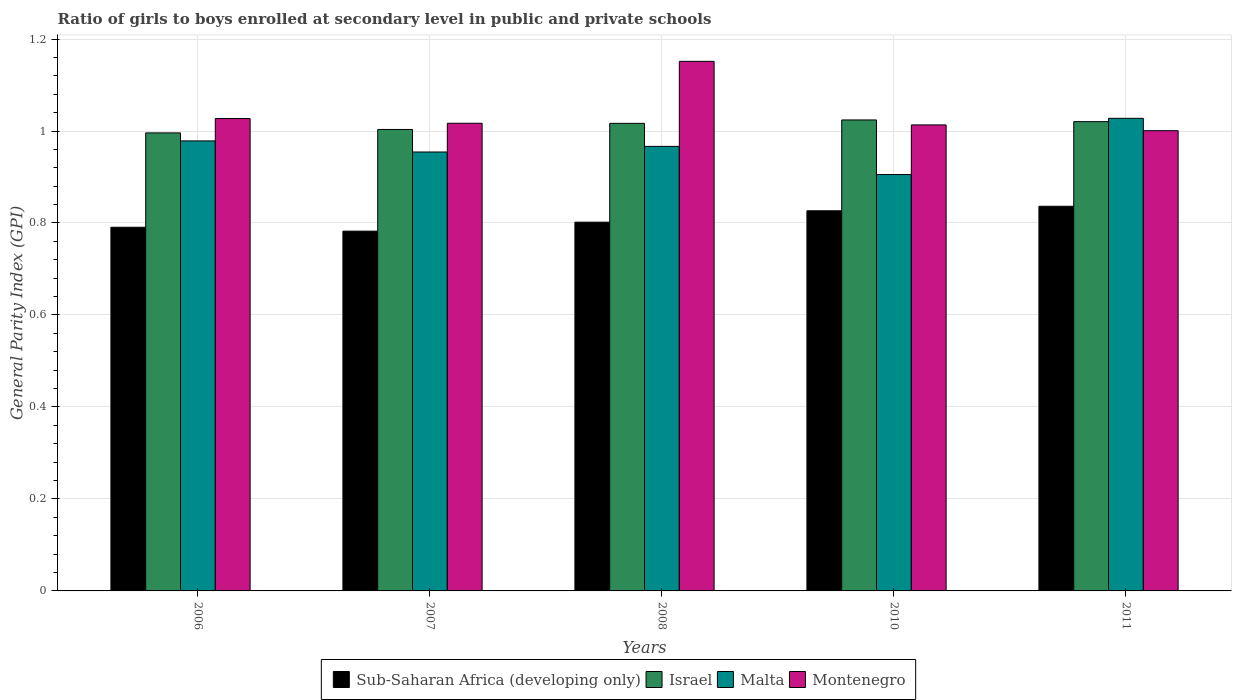How many different coloured bars are there?
Keep it short and to the point. 4. How many groups of bars are there?
Provide a short and direct response. 5. Are the number of bars per tick equal to the number of legend labels?
Provide a succinct answer. Yes. How many bars are there on the 2nd tick from the left?
Keep it short and to the point. 4. How many bars are there on the 1st tick from the right?
Keep it short and to the point. 4. In how many cases, is the number of bars for a given year not equal to the number of legend labels?
Offer a terse response. 0. What is the general parity index in Malta in 2007?
Give a very brief answer. 0.95. Across all years, what is the maximum general parity index in Israel?
Offer a terse response. 1.02. Across all years, what is the minimum general parity index in Israel?
Ensure brevity in your answer.  1. What is the total general parity index in Sub-Saharan Africa (developing only) in the graph?
Make the answer very short. 4.04. What is the difference between the general parity index in Sub-Saharan Africa (developing only) in 2007 and that in 2008?
Offer a very short reply. -0.02. What is the difference between the general parity index in Montenegro in 2007 and the general parity index in Malta in 2006?
Your answer should be compact. 0.04. What is the average general parity index in Israel per year?
Ensure brevity in your answer.  1.01. In the year 2010, what is the difference between the general parity index in Montenegro and general parity index in Israel?
Ensure brevity in your answer.  -0.01. What is the ratio of the general parity index in Malta in 2006 to that in 2008?
Keep it short and to the point. 1.01. Is the difference between the general parity index in Montenegro in 2006 and 2011 greater than the difference between the general parity index in Israel in 2006 and 2011?
Offer a terse response. Yes. What is the difference between the highest and the second highest general parity index in Israel?
Your answer should be very brief. 0. What is the difference between the highest and the lowest general parity index in Montenegro?
Your answer should be compact. 0.15. In how many years, is the general parity index in Sub-Saharan Africa (developing only) greater than the average general parity index in Sub-Saharan Africa (developing only) taken over all years?
Your response must be concise. 2. What does the 1st bar from the left in 2010 represents?
Your answer should be compact. Sub-Saharan Africa (developing only). What does the 1st bar from the right in 2006 represents?
Offer a terse response. Montenegro. Is it the case that in every year, the sum of the general parity index in Sub-Saharan Africa (developing only) and general parity index in Israel is greater than the general parity index in Montenegro?
Your response must be concise. Yes. How many bars are there?
Make the answer very short. 20. Are all the bars in the graph horizontal?
Your response must be concise. No. How many years are there in the graph?
Ensure brevity in your answer.  5. What is the difference between two consecutive major ticks on the Y-axis?
Your response must be concise. 0.2. Are the values on the major ticks of Y-axis written in scientific E-notation?
Keep it short and to the point. No. Does the graph contain grids?
Your answer should be compact. Yes. How many legend labels are there?
Give a very brief answer. 4. How are the legend labels stacked?
Provide a succinct answer. Horizontal. What is the title of the graph?
Offer a terse response. Ratio of girls to boys enrolled at secondary level in public and private schools. What is the label or title of the X-axis?
Provide a succinct answer. Years. What is the label or title of the Y-axis?
Provide a succinct answer. General Parity Index (GPI). What is the General Parity Index (GPI) of Sub-Saharan Africa (developing only) in 2006?
Provide a succinct answer. 0.79. What is the General Parity Index (GPI) of Israel in 2006?
Your answer should be very brief. 1. What is the General Parity Index (GPI) of Malta in 2006?
Offer a terse response. 0.98. What is the General Parity Index (GPI) in Montenegro in 2006?
Your answer should be compact. 1.03. What is the General Parity Index (GPI) in Sub-Saharan Africa (developing only) in 2007?
Keep it short and to the point. 0.78. What is the General Parity Index (GPI) of Israel in 2007?
Provide a succinct answer. 1. What is the General Parity Index (GPI) of Malta in 2007?
Your response must be concise. 0.95. What is the General Parity Index (GPI) in Montenegro in 2007?
Make the answer very short. 1.02. What is the General Parity Index (GPI) in Sub-Saharan Africa (developing only) in 2008?
Keep it short and to the point. 0.8. What is the General Parity Index (GPI) in Israel in 2008?
Ensure brevity in your answer.  1.02. What is the General Parity Index (GPI) of Malta in 2008?
Offer a very short reply. 0.97. What is the General Parity Index (GPI) of Montenegro in 2008?
Offer a terse response. 1.15. What is the General Parity Index (GPI) of Sub-Saharan Africa (developing only) in 2010?
Provide a short and direct response. 0.83. What is the General Parity Index (GPI) of Israel in 2010?
Give a very brief answer. 1.02. What is the General Parity Index (GPI) of Malta in 2010?
Ensure brevity in your answer.  0.91. What is the General Parity Index (GPI) of Montenegro in 2010?
Offer a terse response. 1.01. What is the General Parity Index (GPI) in Sub-Saharan Africa (developing only) in 2011?
Your answer should be compact. 0.84. What is the General Parity Index (GPI) of Israel in 2011?
Offer a terse response. 1.02. What is the General Parity Index (GPI) in Malta in 2011?
Provide a succinct answer. 1.03. What is the General Parity Index (GPI) of Montenegro in 2011?
Ensure brevity in your answer.  1. Across all years, what is the maximum General Parity Index (GPI) of Sub-Saharan Africa (developing only)?
Provide a short and direct response. 0.84. Across all years, what is the maximum General Parity Index (GPI) in Israel?
Your answer should be very brief. 1.02. Across all years, what is the maximum General Parity Index (GPI) of Malta?
Keep it short and to the point. 1.03. Across all years, what is the maximum General Parity Index (GPI) in Montenegro?
Ensure brevity in your answer.  1.15. Across all years, what is the minimum General Parity Index (GPI) of Sub-Saharan Africa (developing only)?
Offer a terse response. 0.78. Across all years, what is the minimum General Parity Index (GPI) in Israel?
Offer a very short reply. 1. Across all years, what is the minimum General Parity Index (GPI) in Malta?
Offer a very short reply. 0.91. Across all years, what is the minimum General Parity Index (GPI) of Montenegro?
Your answer should be compact. 1. What is the total General Parity Index (GPI) in Sub-Saharan Africa (developing only) in the graph?
Ensure brevity in your answer.  4.04. What is the total General Parity Index (GPI) in Israel in the graph?
Your response must be concise. 5.06. What is the total General Parity Index (GPI) in Malta in the graph?
Offer a terse response. 4.83. What is the total General Parity Index (GPI) in Montenegro in the graph?
Provide a short and direct response. 5.21. What is the difference between the General Parity Index (GPI) in Sub-Saharan Africa (developing only) in 2006 and that in 2007?
Keep it short and to the point. 0.01. What is the difference between the General Parity Index (GPI) in Israel in 2006 and that in 2007?
Your answer should be very brief. -0.01. What is the difference between the General Parity Index (GPI) of Malta in 2006 and that in 2007?
Keep it short and to the point. 0.02. What is the difference between the General Parity Index (GPI) in Montenegro in 2006 and that in 2007?
Your response must be concise. 0.01. What is the difference between the General Parity Index (GPI) of Sub-Saharan Africa (developing only) in 2006 and that in 2008?
Keep it short and to the point. -0.01. What is the difference between the General Parity Index (GPI) of Israel in 2006 and that in 2008?
Keep it short and to the point. -0.02. What is the difference between the General Parity Index (GPI) of Malta in 2006 and that in 2008?
Offer a very short reply. 0.01. What is the difference between the General Parity Index (GPI) in Montenegro in 2006 and that in 2008?
Give a very brief answer. -0.12. What is the difference between the General Parity Index (GPI) of Sub-Saharan Africa (developing only) in 2006 and that in 2010?
Give a very brief answer. -0.04. What is the difference between the General Parity Index (GPI) of Israel in 2006 and that in 2010?
Keep it short and to the point. -0.03. What is the difference between the General Parity Index (GPI) of Malta in 2006 and that in 2010?
Make the answer very short. 0.07. What is the difference between the General Parity Index (GPI) in Montenegro in 2006 and that in 2010?
Keep it short and to the point. 0.01. What is the difference between the General Parity Index (GPI) in Sub-Saharan Africa (developing only) in 2006 and that in 2011?
Offer a terse response. -0.05. What is the difference between the General Parity Index (GPI) of Israel in 2006 and that in 2011?
Make the answer very short. -0.02. What is the difference between the General Parity Index (GPI) in Malta in 2006 and that in 2011?
Your response must be concise. -0.05. What is the difference between the General Parity Index (GPI) in Montenegro in 2006 and that in 2011?
Offer a very short reply. 0.03. What is the difference between the General Parity Index (GPI) of Sub-Saharan Africa (developing only) in 2007 and that in 2008?
Offer a terse response. -0.02. What is the difference between the General Parity Index (GPI) in Israel in 2007 and that in 2008?
Your response must be concise. -0.01. What is the difference between the General Parity Index (GPI) of Malta in 2007 and that in 2008?
Your answer should be compact. -0.01. What is the difference between the General Parity Index (GPI) in Montenegro in 2007 and that in 2008?
Make the answer very short. -0.13. What is the difference between the General Parity Index (GPI) of Sub-Saharan Africa (developing only) in 2007 and that in 2010?
Keep it short and to the point. -0.04. What is the difference between the General Parity Index (GPI) in Israel in 2007 and that in 2010?
Your response must be concise. -0.02. What is the difference between the General Parity Index (GPI) of Malta in 2007 and that in 2010?
Give a very brief answer. 0.05. What is the difference between the General Parity Index (GPI) of Montenegro in 2007 and that in 2010?
Offer a very short reply. 0. What is the difference between the General Parity Index (GPI) in Sub-Saharan Africa (developing only) in 2007 and that in 2011?
Offer a terse response. -0.05. What is the difference between the General Parity Index (GPI) of Israel in 2007 and that in 2011?
Offer a very short reply. -0.02. What is the difference between the General Parity Index (GPI) in Malta in 2007 and that in 2011?
Your answer should be very brief. -0.07. What is the difference between the General Parity Index (GPI) in Montenegro in 2007 and that in 2011?
Offer a terse response. 0.02. What is the difference between the General Parity Index (GPI) in Sub-Saharan Africa (developing only) in 2008 and that in 2010?
Keep it short and to the point. -0.02. What is the difference between the General Parity Index (GPI) of Israel in 2008 and that in 2010?
Keep it short and to the point. -0.01. What is the difference between the General Parity Index (GPI) of Malta in 2008 and that in 2010?
Your response must be concise. 0.06. What is the difference between the General Parity Index (GPI) of Montenegro in 2008 and that in 2010?
Your answer should be very brief. 0.14. What is the difference between the General Parity Index (GPI) of Sub-Saharan Africa (developing only) in 2008 and that in 2011?
Provide a short and direct response. -0.03. What is the difference between the General Parity Index (GPI) in Israel in 2008 and that in 2011?
Keep it short and to the point. -0. What is the difference between the General Parity Index (GPI) of Malta in 2008 and that in 2011?
Keep it short and to the point. -0.06. What is the difference between the General Parity Index (GPI) in Montenegro in 2008 and that in 2011?
Ensure brevity in your answer.  0.15. What is the difference between the General Parity Index (GPI) of Sub-Saharan Africa (developing only) in 2010 and that in 2011?
Your answer should be very brief. -0.01. What is the difference between the General Parity Index (GPI) in Israel in 2010 and that in 2011?
Ensure brevity in your answer.  0. What is the difference between the General Parity Index (GPI) of Malta in 2010 and that in 2011?
Offer a terse response. -0.12. What is the difference between the General Parity Index (GPI) in Montenegro in 2010 and that in 2011?
Provide a short and direct response. 0.01. What is the difference between the General Parity Index (GPI) of Sub-Saharan Africa (developing only) in 2006 and the General Parity Index (GPI) of Israel in 2007?
Offer a very short reply. -0.21. What is the difference between the General Parity Index (GPI) of Sub-Saharan Africa (developing only) in 2006 and the General Parity Index (GPI) of Malta in 2007?
Offer a terse response. -0.16. What is the difference between the General Parity Index (GPI) in Sub-Saharan Africa (developing only) in 2006 and the General Parity Index (GPI) in Montenegro in 2007?
Offer a very short reply. -0.23. What is the difference between the General Parity Index (GPI) in Israel in 2006 and the General Parity Index (GPI) in Malta in 2007?
Your response must be concise. 0.04. What is the difference between the General Parity Index (GPI) in Israel in 2006 and the General Parity Index (GPI) in Montenegro in 2007?
Offer a very short reply. -0.02. What is the difference between the General Parity Index (GPI) of Malta in 2006 and the General Parity Index (GPI) of Montenegro in 2007?
Give a very brief answer. -0.04. What is the difference between the General Parity Index (GPI) of Sub-Saharan Africa (developing only) in 2006 and the General Parity Index (GPI) of Israel in 2008?
Your answer should be very brief. -0.23. What is the difference between the General Parity Index (GPI) of Sub-Saharan Africa (developing only) in 2006 and the General Parity Index (GPI) of Malta in 2008?
Make the answer very short. -0.18. What is the difference between the General Parity Index (GPI) in Sub-Saharan Africa (developing only) in 2006 and the General Parity Index (GPI) in Montenegro in 2008?
Give a very brief answer. -0.36. What is the difference between the General Parity Index (GPI) in Israel in 2006 and the General Parity Index (GPI) in Malta in 2008?
Your answer should be very brief. 0.03. What is the difference between the General Parity Index (GPI) of Israel in 2006 and the General Parity Index (GPI) of Montenegro in 2008?
Offer a terse response. -0.16. What is the difference between the General Parity Index (GPI) of Malta in 2006 and the General Parity Index (GPI) of Montenegro in 2008?
Keep it short and to the point. -0.17. What is the difference between the General Parity Index (GPI) of Sub-Saharan Africa (developing only) in 2006 and the General Parity Index (GPI) of Israel in 2010?
Your answer should be compact. -0.23. What is the difference between the General Parity Index (GPI) in Sub-Saharan Africa (developing only) in 2006 and the General Parity Index (GPI) in Malta in 2010?
Ensure brevity in your answer.  -0.11. What is the difference between the General Parity Index (GPI) of Sub-Saharan Africa (developing only) in 2006 and the General Parity Index (GPI) of Montenegro in 2010?
Provide a succinct answer. -0.22. What is the difference between the General Parity Index (GPI) of Israel in 2006 and the General Parity Index (GPI) of Malta in 2010?
Provide a short and direct response. 0.09. What is the difference between the General Parity Index (GPI) of Israel in 2006 and the General Parity Index (GPI) of Montenegro in 2010?
Make the answer very short. -0.02. What is the difference between the General Parity Index (GPI) in Malta in 2006 and the General Parity Index (GPI) in Montenegro in 2010?
Make the answer very short. -0.03. What is the difference between the General Parity Index (GPI) of Sub-Saharan Africa (developing only) in 2006 and the General Parity Index (GPI) of Israel in 2011?
Your answer should be compact. -0.23. What is the difference between the General Parity Index (GPI) in Sub-Saharan Africa (developing only) in 2006 and the General Parity Index (GPI) in Malta in 2011?
Your answer should be compact. -0.24. What is the difference between the General Parity Index (GPI) of Sub-Saharan Africa (developing only) in 2006 and the General Parity Index (GPI) of Montenegro in 2011?
Make the answer very short. -0.21. What is the difference between the General Parity Index (GPI) in Israel in 2006 and the General Parity Index (GPI) in Malta in 2011?
Offer a terse response. -0.03. What is the difference between the General Parity Index (GPI) of Israel in 2006 and the General Parity Index (GPI) of Montenegro in 2011?
Provide a short and direct response. -0. What is the difference between the General Parity Index (GPI) in Malta in 2006 and the General Parity Index (GPI) in Montenegro in 2011?
Make the answer very short. -0.02. What is the difference between the General Parity Index (GPI) in Sub-Saharan Africa (developing only) in 2007 and the General Parity Index (GPI) in Israel in 2008?
Your response must be concise. -0.23. What is the difference between the General Parity Index (GPI) in Sub-Saharan Africa (developing only) in 2007 and the General Parity Index (GPI) in Malta in 2008?
Offer a very short reply. -0.18. What is the difference between the General Parity Index (GPI) of Sub-Saharan Africa (developing only) in 2007 and the General Parity Index (GPI) of Montenegro in 2008?
Ensure brevity in your answer.  -0.37. What is the difference between the General Parity Index (GPI) of Israel in 2007 and the General Parity Index (GPI) of Malta in 2008?
Provide a succinct answer. 0.04. What is the difference between the General Parity Index (GPI) of Israel in 2007 and the General Parity Index (GPI) of Montenegro in 2008?
Offer a very short reply. -0.15. What is the difference between the General Parity Index (GPI) of Malta in 2007 and the General Parity Index (GPI) of Montenegro in 2008?
Offer a very short reply. -0.2. What is the difference between the General Parity Index (GPI) of Sub-Saharan Africa (developing only) in 2007 and the General Parity Index (GPI) of Israel in 2010?
Give a very brief answer. -0.24. What is the difference between the General Parity Index (GPI) of Sub-Saharan Africa (developing only) in 2007 and the General Parity Index (GPI) of Malta in 2010?
Give a very brief answer. -0.12. What is the difference between the General Parity Index (GPI) of Sub-Saharan Africa (developing only) in 2007 and the General Parity Index (GPI) of Montenegro in 2010?
Your answer should be very brief. -0.23. What is the difference between the General Parity Index (GPI) of Israel in 2007 and the General Parity Index (GPI) of Malta in 2010?
Provide a succinct answer. 0.1. What is the difference between the General Parity Index (GPI) of Israel in 2007 and the General Parity Index (GPI) of Montenegro in 2010?
Your answer should be compact. -0.01. What is the difference between the General Parity Index (GPI) of Malta in 2007 and the General Parity Index (GPI) of Montenegro in 2010?
Provide a succinct answer. -0.06. What is the difference between the General Parity Index (GPI) in Sub-Saharan Africa (developing only) in 2007 and the General Parity Index (GPI) in Israel in 2011?
Your answer should be compact. -0.24. What is the difference between the General Parity Index (GPI) of Sub-Saharan Africa (developing only) in 2007 and the General Parity Index (GPI) of Malta in 2011?
Your answer should be compact. -0.25. What is the difference between the General Parity Index (GPI) in Sub-Saharan Africa (developing only) in 2007 and the General Parity Index (GPI) in Montenegro in 2011?
Provide a succinct answer. -0.22. What is the difference between the General Parity Index (GPI) in Israel in 2007 and the General Parity Index (GPI) in Malta in 2011?
Your answer should be very brief. -0.02. What is the difference between the General Parity Index (GPI) of Israel in 2007 and the General Parity Index (GPI) of Montenegro in 2011?
Offer a terse response. 0. What is the difference between the General Parity Index (GPI) of Malta in 2007 and the General Parity Index (GPI) of Montenegro in 2011?
Keep it short and to the point. -0.05. What is the difference between the General Parity Index (GPI) in Sub-Saharan Africa (developing only) in 2008 and the General Parity Index (GPI) in Israel in 2010?
Provide a succinct answer. -0.22. What is the difference between the General Parity Index (GPI) in Sub-Saharan Africa (developing only) in 2008 and the General Parity Index (GPI) in Malta in 2010?
Provide a succinct answer. -0.1. What is the difference between the General Parity Index (GPI) in Sub-Saharan Africa (developing only) in 2008 and the General Parity Index (GPI) in Montenegro in 2010?
Your answer should be compact. -0.21. What is the difference between the General Parity Index (GPI) in Israel in 2008 and the General Parity Index (GPI) in Malta in 2010?
Provide a succinct answer. 0.11. What is the difference between the General Parity Index (GPI) of Israel in 2008 and the General Parity Index (GPI) of Montenegro in 2010?
Ensure brevity in your answer.  0. What is the difference between the General Parity Index (GPI) in Malta in 2008 and the General Parity Index (GPI) in Montenegro in 2010?
Ensure brevity in your answer.  -0.05. What is the difference between the General Parity Index (GPI) of Sub-Saharan Africa (developing only) in 2008 and the General Parity Index (GPI) of Israel in 2011?
Keep it short and to the point. -0.22. What is the difference between the General Parity Index (GPI) in Sub-Saharan Africa (developing only) in 2008 and the General Parity Index (GPI) in Malta in 2011?
Keep it short and to the point. -0.23. What is the difference between the General Parity Index (GPI) of Sub-Saharan Africa (developing only) in 2008 and the General Parity Index (GPI) of Montenegro in 2011?
Offer a terse response. -0.2. What is the difference between the General Parity Index (GPI) of Israel in 2008 and the General Parity Index (GPI) of Malta in 2011?
Keep it short and to the point. -0.01. What is the difference between the General Parity Index (GPI) in Israel in 2008 and the General Parity Index (GPI) in Montenegro in 2011?
Your answer should be compact. 0.02. What is the difference between the General Parity Index (GPI) in Malta in 2008 and the General Parity Index (GPI) in Montenegro in 2011?
Keep it short and to the point. -0.03. What is the difference between the General Parity Index (GPI) of Sub-Saharan Africa (developing only) in 2010 and the General Parity Index (GPI) of Israel in 2011?
Your answer should be compact. -0.19. What is the difference between the General Parity Index (GPI) of Sub-Saharan Africa (developing only) in 2010 and the General Parity Index (GPI) of Malta in 2011?
Provide a short and direct response. -0.2. What is the difference between the General Parity Index (GPI) in Sub-Saharan Africa (developing only) in 2010 and the General Parity Index (GPI) in Montenegro in 2011?
Make the answer very short. -0.17. What is the difference between the General Parity Index (GPI) of Israel in 2010 and the General Parity Index (GPI) of Malta in 2011?
Provide a short and direct response. -0. What is the difference between the General Parity Index (GPI) in Israel in 2010 and the General Parity Index (GPI) in Montenegro in 2011?
Give a very brief answer. 0.02. What is the difference between the General Parity Index (GPI) of Malta in 2010 and the General Parity Index (GPI) of Montenegro in 2011?
Offer a terse response. -0.1. What is the average General Parity Index (GPI) of Sub-Saharan Africa (developing only) per year?
Give a very brief answer. 0.81. What is the average General Parity Index (GPI) of Israel per year?
Your answer should be compact. 1.01. What is the average General Parity Index (GPI) of Malta per year?
Give a very brief answer. 0.97. What is the average General Parity Index (GPI) in Montenegro per year?
Make the answer very short. 1.04. In the year 2006, what is the difference between the General Parity Index (GPI) in Sub-Saharan Africa (developing only) and General Parity Index (GPI) in Israel?
Offer a terse response. -0.21. In the year 2006, what is the difference between the General Parity Index (GPI) in Sub-Saharan Africa (developing only) and General Parity Index (GPI) in Malta?
Provide a succinct answer. -0.19. In the year 2006, what is the difference between the General Parity Index (GPI) in Sub-Saharan Africa (developing only) and General Parity Index (GPI) in Montenegro?
Provide a succinct answer. -0.24. In the year 2006, what is the difference between the General Parity Index (GPI) of Israel and General Parity Index (GPI) of Malta?
Your answer should be compact. 0.02. In the year 2006, what is the difference between the General Parity Index (GPI) in Israel and General Parity Index (GPI) in Montenegro?
Offer a terse response. -0.03. In the year 2006, what is the difference between the General Parity Index (GPI) in Malta and General Parity Index (GPI) in Montenegro?
Provide a succinct answer. -0.05. In the year 2007, what is the difference between the General Parity Index (GPI) in Sub-Saharan Africa (developing only) and General Parity Index (GPI) in Israel?
Your answer should be compact. -0.22. In the year 2007, what is the difference between the General Parity Index (GPI) of Sub-Saharan Africa (developing only) and General Parity Index (GPI) of Malta?
Provide a short and direct response. -0.17. In the year 2007, what is the difference between the General Parity Index (GPI) in Sub-Saharan Africa (developing only) and General Parity Index (GPI) in Montenegro?
Offer a very short reply. -0.23. In the year 2007, what is the difference between the General Parity Index (GPI) in Israel and General Parity Index (GPI) in Malta?
Offer a very short reply. 0.05. In the year 2007, what is the difference between the General Parity Index (GPI) of Israel and General Parity Index (GPI) of Montenegro?
Offer a very short reply. -0.01. In the year 2007, what is the difference between the General Parity Index (GPI) of Malta and General Parity Index (GPI) of Montenegro?
Offer a very short reply. -0.06. In the year 2008, what is the difference between the General Parity Index (GPI) in Sub-Saharan Africa (developing only) and General Parity Index (GPI) in Israel?
Keep it short and to the point. -0.21. In the year 2008, what is the difference between the General Parity Index (GPI) in Sub-Saharan Africa (developing only) and General Parity Index (GPI) in Malta?
Offer a terse response. -0.16. In the year 2008, what is the difference between the General Parity Index (GPI) in Sub-Saharan Africa (developing only) and General Parity Index (GPI) in Montenegro?
Give a very brief answer. -0.35. In the year 2008, what is the difference between the General Parity Index (GPI) of Israel and General Parity Index (GPI) of Malta?
Your answer should be very brief. 0.05. In the year 2008, what is the difference between the General Parity Index (GPI) in Israel and General Parity Index (GPI) in Montenegro?
Give a very brief answer. -0.13. In the year 2008, what is the difference between the General Parity Index (GPI) of Malta and General Parity Index (GPI) of Montenegro?
Offer a terse response. -0.18. In the year 2010, what is the difference between the General Parity Index (GPI) in Sub-Saharan Africa (developing only) and General Parity Index (GPI) in Israel?
Your answer should be compact. -0.2. In the year 2010, what is the difference between the General Parity Index (GPI) of Sub-Saharan Africa (developing only) and General Parity Index (GPI) of Malta?
Provide a short and direct response. -0.08. In the year 2010, what is the difference between the General Parity Index (GPI) of Sub-Saharan Africa (developing only) and General Parity Index (GPI) of Montenegro?
Your answer should be very brief. -0.19. In the year 2010, what is the difference between the General Parity Index (GPI) in Israel and General Parity Index (GPI) in Malta?
Offer a terse response. 0.12. In the year 2010, what is the difference between the General Parity Index (GPI) of Israel and General Parity Index (GPI) of Montenegro?
Your response must be concise. 0.01. In the year 2010, what is the difference between the General Parity Index (GPI) in Malta and General Parity Index (GPI) in Montenegro?
Your answer should be compact. -0.11. In the year 2011, what is the difference between the General Parity Index (GPI) of Sub-Saharan Africa (developing only) and General Parity Index (GPI) of Israel?
Give a very brief answer. -0.18. In the year 2011, what is the difference between the General Parity Index (GPI) of Sub-Saharan Africa (developing only) and General Parity Index (GPI) of Malta?
Keep it short and to the point. -0.19. In the year 2011, what is the difference between the General Parity Index (GPI) of Sub-Saharan Africa (developing only) and General Parity Index (GPI) of Montenegro?
Your answer should be compact. -0.16. In the year 2011, what is the difference between the General Parity Index (GPI) in Israel and General Parity Index (GPI) in Malta?
Ensure brevity in your answer.  -0.01. In the year 2011, what is the difference between the General Parity Index (GPI) in Israel and General Parity Index (GPI) in Montenegro?
Keep it short and to the point. 0.02. In the year 2011, what is the difference between the General Parity Index (GPI) of Malta and General Parity Index (GPI) of Montenegro?
Provide a short and direct response. 0.03. What is the ratio of the General Parity Index (GPI) of Sub-Saharan Africa (developing only) in 2006 to that in 2007?
Keep it short and to the point. 1.01. What is the ratio of the General Parity Index (GPI) in Malta in 2006 to that in 2007?
Make the answer very short. 1.03. What is the ratio of the General Parity Index (GPI) of Sub-Saharan Africa (developing only) in 2006 to that in 2008?
Offer a very short reply. 0.99. What is the ratio of the General Parity Index (GPI) of Israel in 2006 to that in 2008?
Your answer should be very brief. 0.98. What is the ratio of the General Parity Index (GPI) in Malta in 2006 to that in 2008?
Provide a short and direct response. 1.01. What is the ratio of the General Parity Index (GPI) of Montenegro in 2006 to that in 2008?
Offer a terse response. 0.89. What is the ratio of the General Parity Index (GPI) of Sub-Saharan Africa (developing only) in 2006 to that in 2010?
Keep it short and to the point. 0.96. What is the ratio of the General Parity Index (GPI) in Israel in 2006 to that in 2010?
Offer a terse response. 0.97. What is the ratio of the General Parity Index (GPI) in Malta in 2006 to that in 2010?
Offer a terse response. 1.08. What is the ratio of the General Parity Index (GPI) in Montenegro in 2006 to that in 2010?
Offer a terse response. 1.01. What is the ratio of the General Parity Index (GPI) of Sub-Saharan Africa (developing only) in 2006 to that in 2011?
Provide a succinct answer. 0.95. What is the ratio of the General Parity Index (GPI) in Israel in 2006 to that in 2011?
Provide a short and direct response. 0.98. What is the ratio of the General Parity Index (GPI) of Malta in 2006 to that in 2011?
Your answer should be compact. 0.95. What is the ratio of the General Parity Index (GPI) of Montenegro in 2006 to that in 2011?
Offer a very short reply. 1.03. What is the ratio of the General Parity Index (GPI) of Sub-Saharan Africa (developing only) in 2007 to that in 2008?
Provide a succinct answer. 0.98. What is the ratio of the General Parity Index (GPI) in Israel in 2007 to that in 2008?
Your response must be concise. 0.99. What is the ratio of the General Parity Index (GPI) in Malta in 2007 to that in 2008?
Offer a very short reply. 0.99. What is the ratio of the General Parity Index (GPI) in Montenegro in 2007 to that in 2008?
Keep it short and to the point. 0.88. What is the ratio of the General Parity Index (GPI) of Sub-Saharan Africa (developing only) in 2007 to that in 2010?
Make the answer very short. 0.95. What is the ratio of the General Parity Index (GPI) in Israel in 2007 to that in 2010?
Your answer should be very brief. 0.98. What is the ratio of the General Parity Index (GPI) in Malta in 2007 to that in 2010?
Make the answer very short. 1.05. What is the ratio of the General Parity Index (GPI) of Sub-Saharan Africa (developing only) in 2007 to that in 2011?
Ensure brevity in your answer.  0.94. What is the ratio of the General Parity Index (GPI) in Israel in 2007 to that in 2011?
Offer a terse response. 0.98. What is the ratio of the General Parity Index (GPI) of Malta in 2007 to that in 2011?
Provide a succinct answer. 0.93. What is the ratio of the General Parity Index (GPI) in Montenegro in 2007 to that in 2011?
Your response must be concise. 1.02. What is the ratio of the General Parity Index (GPI) of Sub-Saharan Africa (developing only) in 2008 to that in 2010?
Provide a succinct answer. 0.97. What is the ratio of the General Parity Index (GPI) in Malta in 2008 to that in 2010?
Make the answer very short. 1.07. What is the ratio of the General Parity Index (GPI) in Montenegro in 2008 to that in 2010?
Keep it short and to the point. 1.14. What is the ratio of the General Parity Index (GPI) of Sub-Saharan Africa (developing only) in 2008 to that in 2011?
Offer a very short reply. 0.96. What is the ratio of the General Parity Index (GPI) in Malta in 2008 to that in 2011?
Give a very brief answer. 0.94. What is the ratio of the General Parity Index (GPI) in Montenegro in 2008 to that in 2011?
Offer a terse response. 1.15. What is the ratio of the General Parity Index (GPI) in Malta in 2010 to that in 2011?
Provide a short and direct response. 0.88. What is the ratio of the General Parity Index (GPI) in Montenegro in 2010 to that in 2011?
Your answer should be compact. 1.01. What is the difference between the highest and the second highest General Parity Index (GPI) in Sub-Saharan Africa (developing only)?
Offer a terse response. 0.01. What is the difference between the highest and the second highest General Parity Index (GPI) in Israel?
Make the answer very short. 0. What is the difference between the highest and the second highest General Parity Index (GPI) in Malta?
Provide a succinct answer. 0.05. What is the difference between the highest and the second highest General Parity Index (GPI) of Montenegro?
Offer a very short reply. 0.12. What is the difference between the highest and the lowest General Parity Index (GPI) of Sub-Saharan Africa (developing only)?
Offer a terse response. 0.05. What is the difference between the highest and the lowest General Parity Index (GPI) in Israel?
Offer a very short reply. 0.03. What is the difference between the highest and the lowest General Parity Index (GPI) in Malta?
Give a very brief answer. 0.12. What is the difference between the highest and the lowest General Parity Index (GPI) in Montenegro?
Your answer should be very brief. 0.15. 